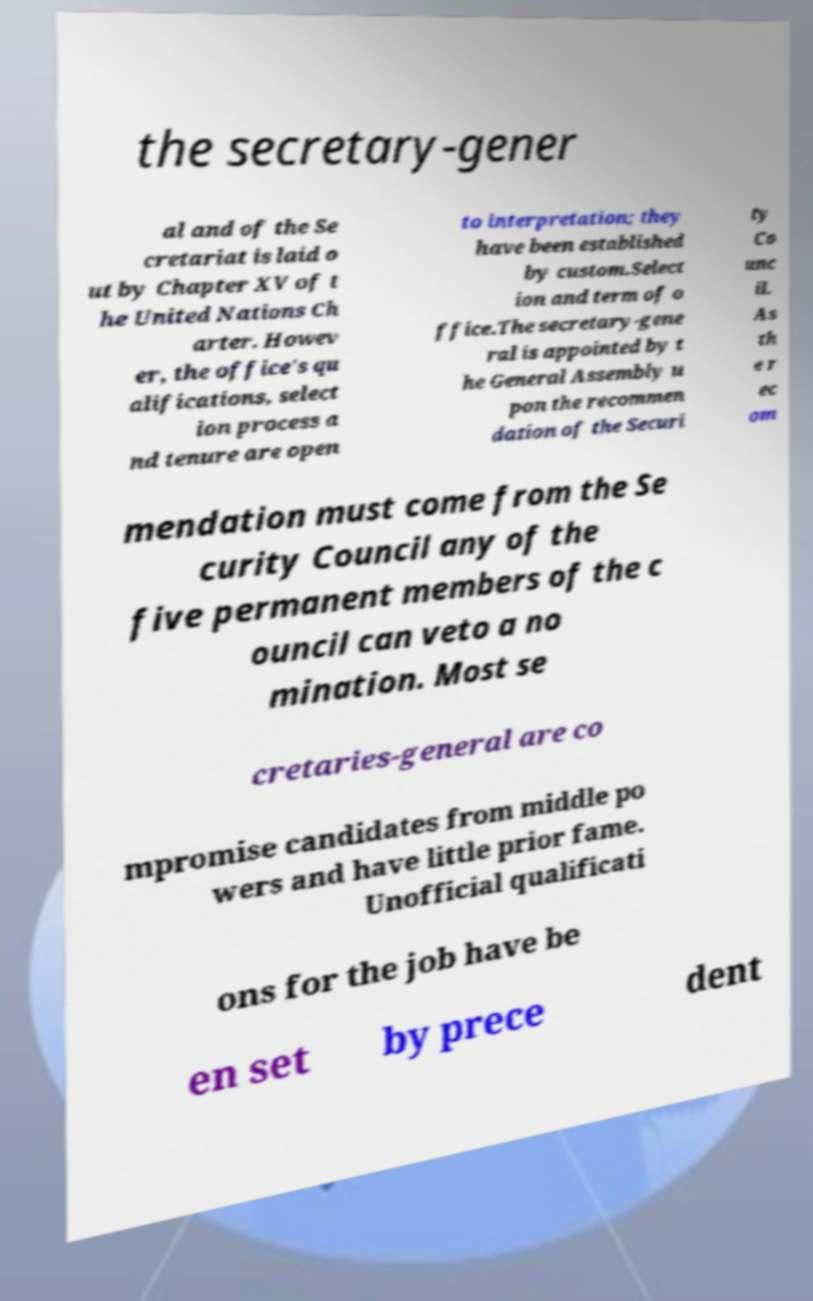For documentation purposes, I need the text within this image transcribed. Could you provide that? the secretary-gener al and of the Se cretariat is laid o ut by Chapter XV of t he United Nations Ch arter. Howev er, the office's qu alifications, select ion process a nd tenure are open to interpretation; they have been established by custom.Select ion and term of o ffice.The secretary-gene ral is appointed by t he General Assembly u pon the recommen dation of the Securi ty Co unc il. As th e r ec om mendation must come from the Se curity Council any of the five permanent members of the c ouncil can veto a no mination. Most se cretaries-general are co mpromise candidates from middle po wers and have little prior fame. Unofficial qualificati ons for the job have be en set by prece dent 